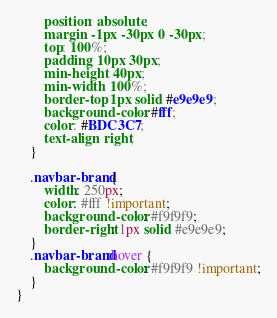<code> <loc_0><loc_0><loc_500><loc_500><_CSS_>        position: absolute;
        margin: -1px -30px 0 -30px;
        top: 100%;
        padding: 10px 30px;
        min-height: 40px;
        min-width: 100%;
        border-top: 1px solid #e9e9e9;
        background-color: #fff;
        color: #BDC3C7;
        text-align: right;
    }

    .navbar-brand {
        width: 250px;
        color: #fff !important;
        background-color: #f9f9f9;
        border-right: 1px solid #e9e9e9;
    }
    .navbar-brand:hover {
        background-color: #f9f9f9 !important;
    }
}
</code> 